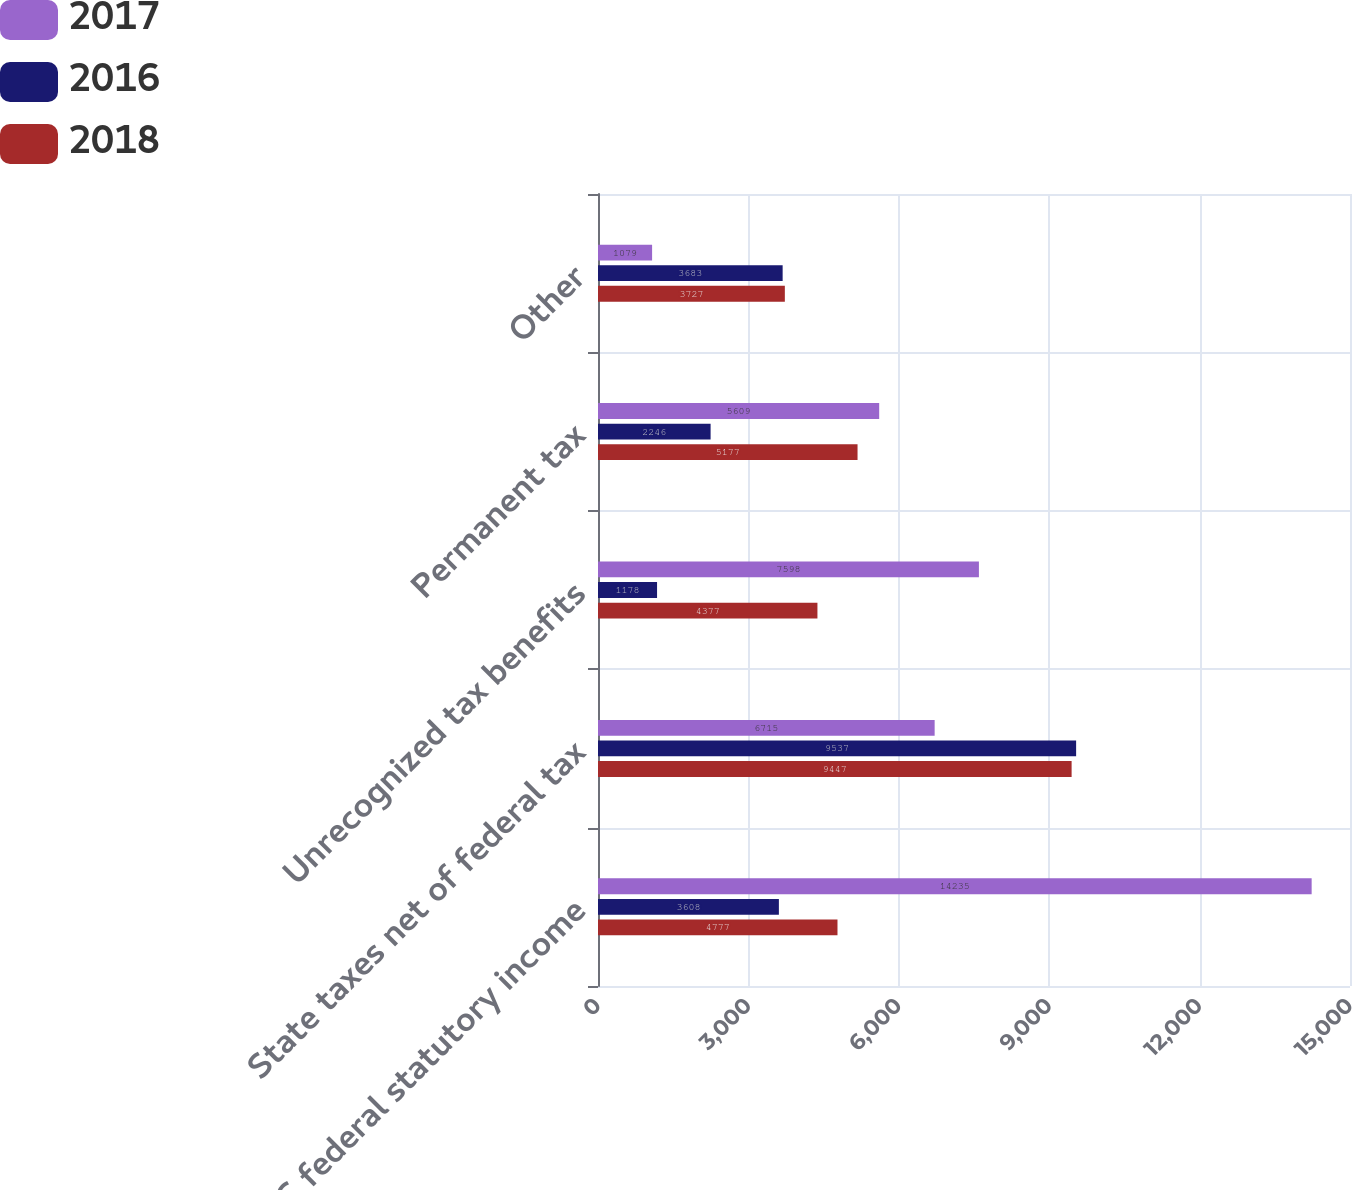<chart> <loc_0><loc_0><loc_500><loc_500><stacked_bar_chart><ecel><fcel>US federal statutory income<fcel>State taxes net of federal tax<fcel>Unrecognized tax benefits<fcel>Permanent tax<fcel>Other<nl><fcel>2017<fcel>14235<fcel>6715<fcel>7598<fcel>5609<fcel>1079<nl><fcel>2016<fcel>3608<fcel>9537<fcel>1178<fcel>2246<fcel>3683<nl><fcel>2018<fcel>4777<fcel>9447<fcel>4377<fcel>5177<fcel>3727<nl></chart> 